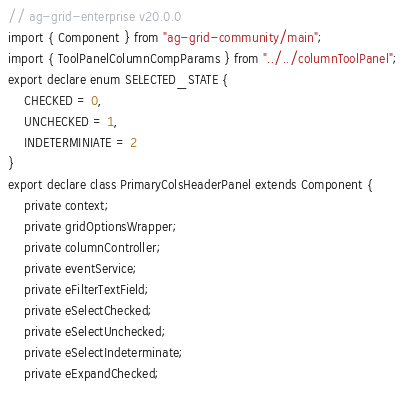Convert code to text. <code><loc_0><loc_0><loc_500><loc_500><_TypeScript_>// ag-grid-enterprise v20.0.0
import { Component } from "ag-grid-community/main";
import { ToolPanelColumnCompParams } from "../../columnToolPanel";
export declare enum SELECTED_STATE {
    CHECKED = 0,
    UNCHECKED = 1,
    INDETERMINIATE = 2
}
export declare class PrimaryColsHeaderPanel extends Component {
    private context;
    private gridOptionsWrapper;
    private columnController;
    private eventService;
    private eFilterTextField;
    private eSelectChecked;
    private eSelectUnchecked;
    private eSelectIndeterminate;
    private eExpandChecked;</code> 